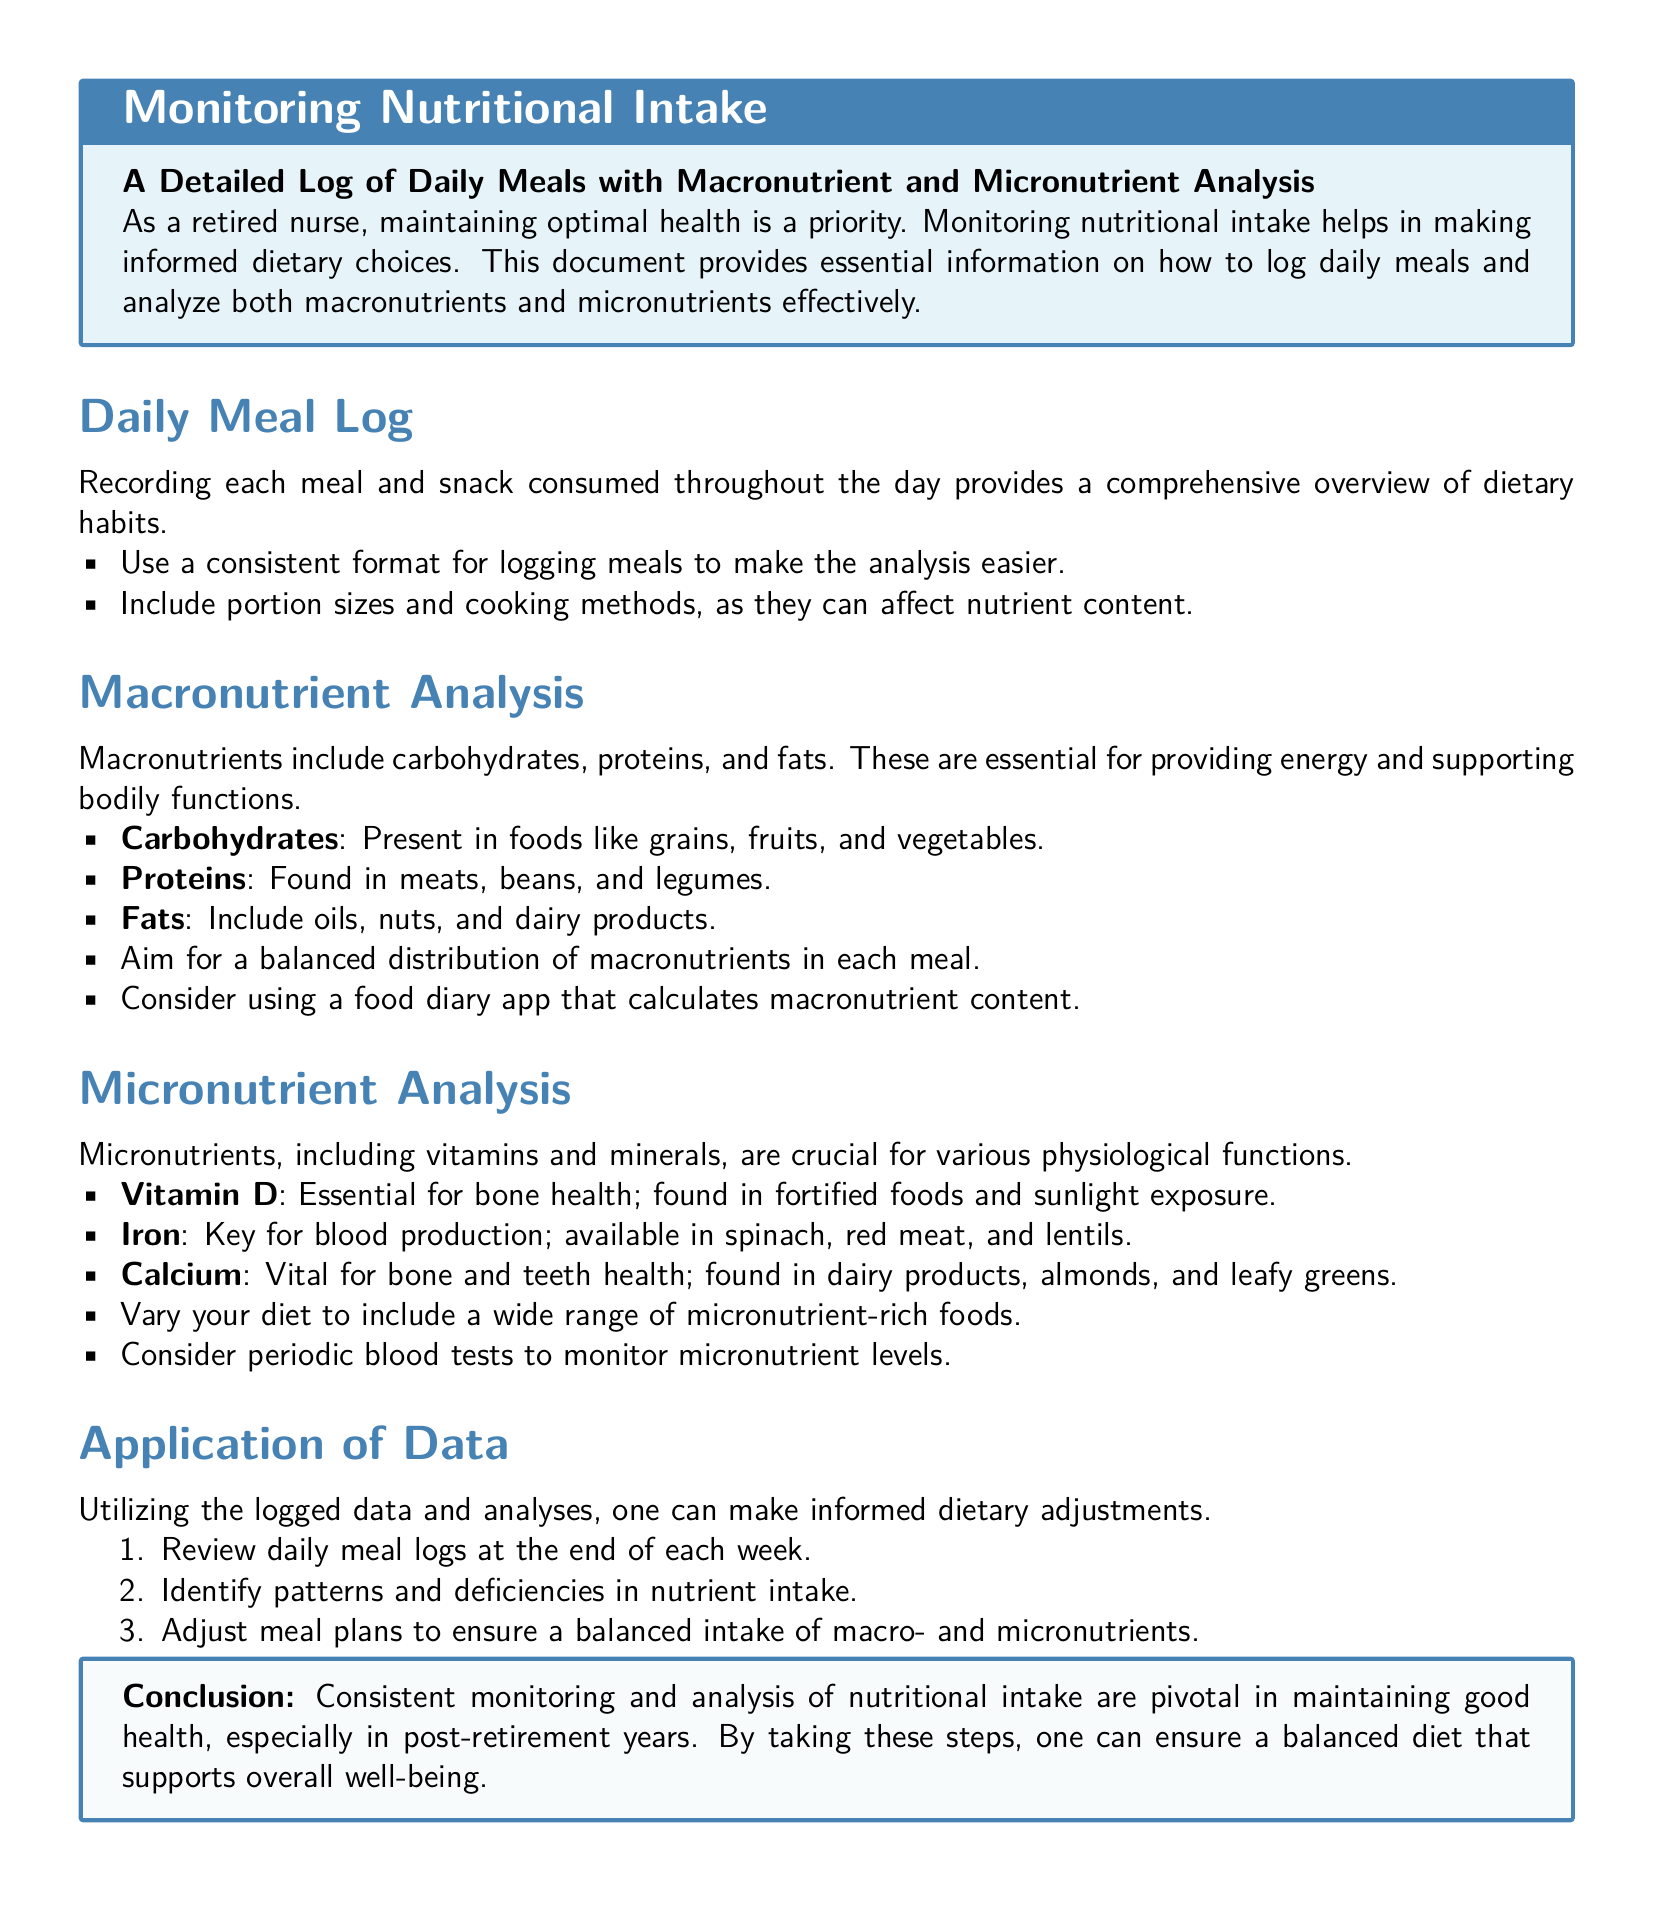What are the three macronutrients? The document lists carbohydrates, proteins, and fats as the three macronutrients essential for energy and bodily functions.
Answer: carbohydrates, proteins, and fats What vitamin is essential for bone health? The document states that Vitamin D is essential for bone health and can be found in fortified foods and sunlight exposure.
Answer: Vitamin D What types of foods should be logged? The document advises to log daily meals and snacks consumed throughout the day for a comprehensive overview of dietary habits.
Answer: meals and snacks What is a suggested method to monitor micronutrient levels? The document suggests considering periodic blood tests to monitor micronutrient levels for adequate intake.
Answer: periodic blood tests What should be reviewed at the end of each week? The document mentions reviewing daily meal logs at the end of each week to identify patterns and deficiencies in nutrient intake.
Answer: daily meal logs Where can carbohydrates be found? The document points out that carbohydrates are present in foods like grains, fruits, and vegetables.
Answer: grains, fruits, and vegetables What is the ideal outcome of dietary monitoring? The document concludes that consistent monitoring and analysis of nutritional intake lead to maintaining good health, especially post-retirement.
Answer: maintaining good health What color is associated with the title box? The document shows that the title box is colored light blue with a border in nurse blue.
Answer: light blue 